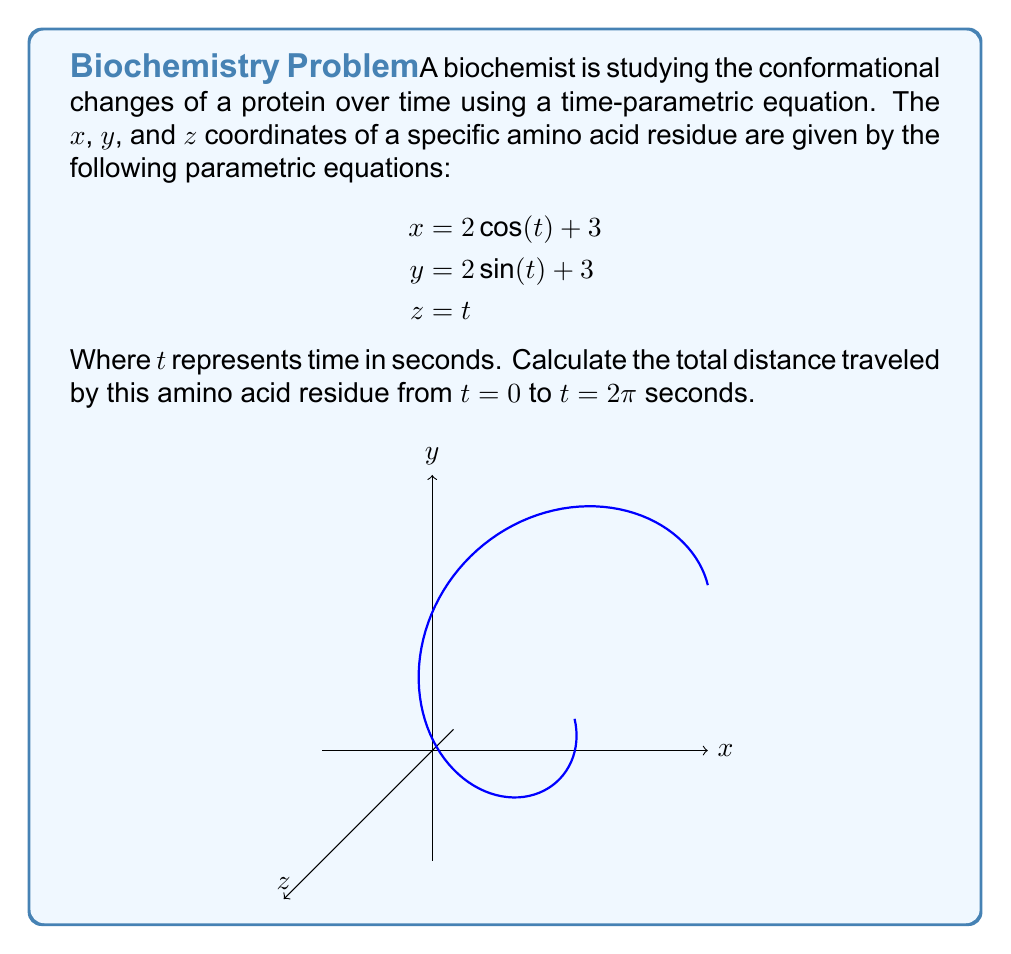Could you help me with this problem? To solve this problem, we'll follow these steps:

1) The parametric equations describe a helical path in 3D space. To find the total distance traveled, we need to calculate the arc length of this curve.

2) The formula for arc length in 3D parametric equations is:

   $$L = \int_a^b \sqrt{\left(\frac{dx}{dt}\right)^2 + \left(\frac{dy}{dt}\right)^2 + \left(\frac{dz}{dt}\right)^2} dt$$

3) Let's calculate the derivatives:
   $$\frac{dx}{dt} = -2\sin(t)$$
   $$\frac{dy}{dt} = 2\cos(t)$$
   $$\frac{dz}{dt} = 1$$

4) Substituting these into the arc length formula:

   $$L = \int_0^{2\pi} \sqrt{(-2\sin(t))^2 + (2\cos(t))^2 + 1^2} dt$$

5) Simplify under the square root:

   $$L = \int_0^{2\pi} \sqrt{4\sin^2(t) + 4\cos^2(t) + 1} dt$$

6) Recall the trigonometric identity $\sin^2(t) + \cos^2(t) = 1$:

   $$L = \int_0^{2\pi} \sqrt{4(1) + 1} dt = \int_0^{2\pi} \sqrt{5} dt$$

7) $\sqrt{5}$ is a constant, so we can take it out of the integral:

   $$L = \sqrt{5} \int_0^{2\pi} dt = \sqrt{5} [t]_0^{2\pi} = \sqrt{5} (2\pi - 0) = 2\pi\sqrt{5}$$

Therefore, the total distance traveled by the amino acid residue is $2\pi\sqrt{5}$ units.
Answer: $2\pi\sqrt{5}$ units 